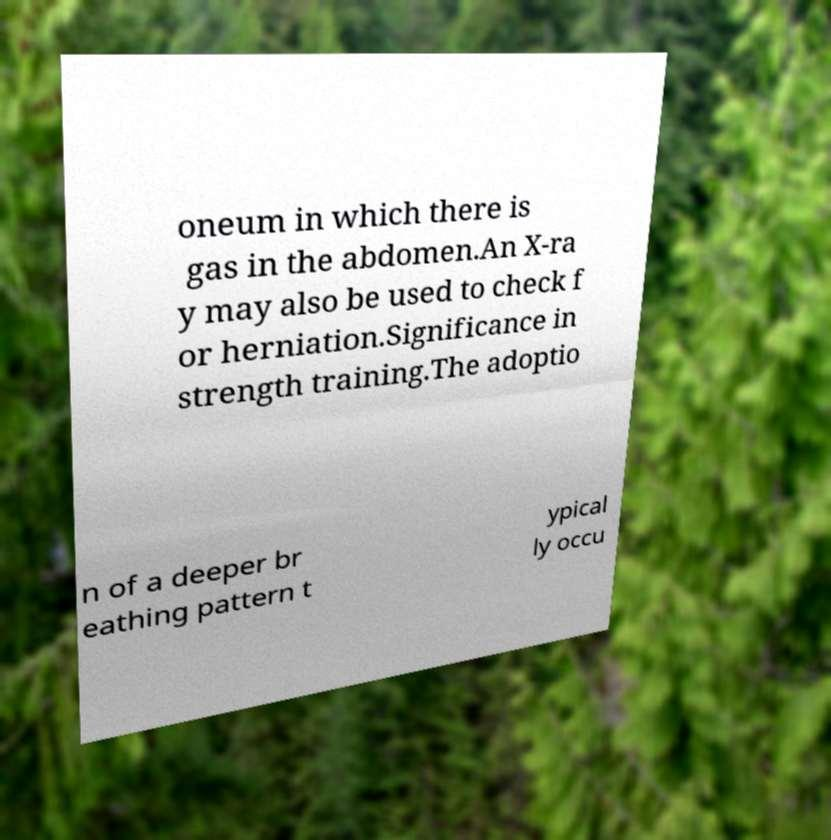What messages or text are displayed in this image? I need them in a readable, typed format. oneum in which there is gas in the abdomen.An X-ra y may also be used to check f or herniation.Significance in strength training.The adoptio n of a deeper br eathing pattern t ypical ly occu 